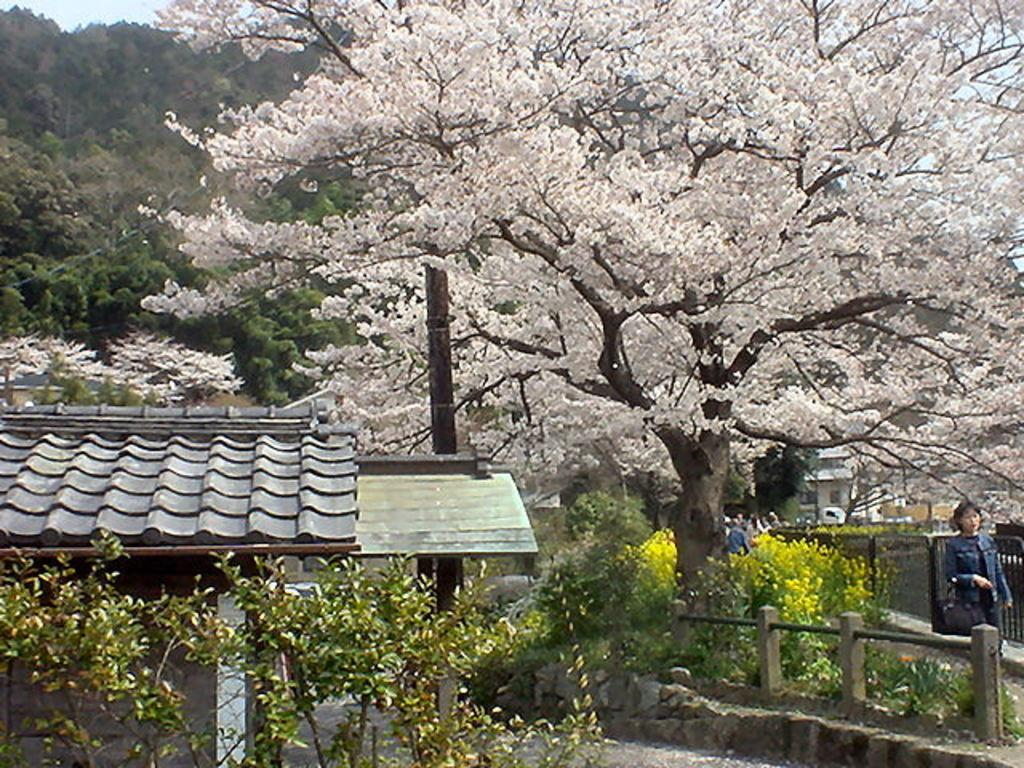What structure is located on the left side of the image? There is a shed on the left side of the image. What is happening on the right side of the image? There is a lady walking on the right side of the image. What can be seen in the background of the image? There are trees and bushes in the background of the image. Are there any other people visible in the image? Yes, there are people in the background of the image. What type of pear is being held by the lady in the image? There is no pear present in the image; the lady is simply walking. Can you tell me how many teeth the lady has in the image? There is no way to determine the number of teeth the lady has in the image, as it is not possible to see her teeth. 